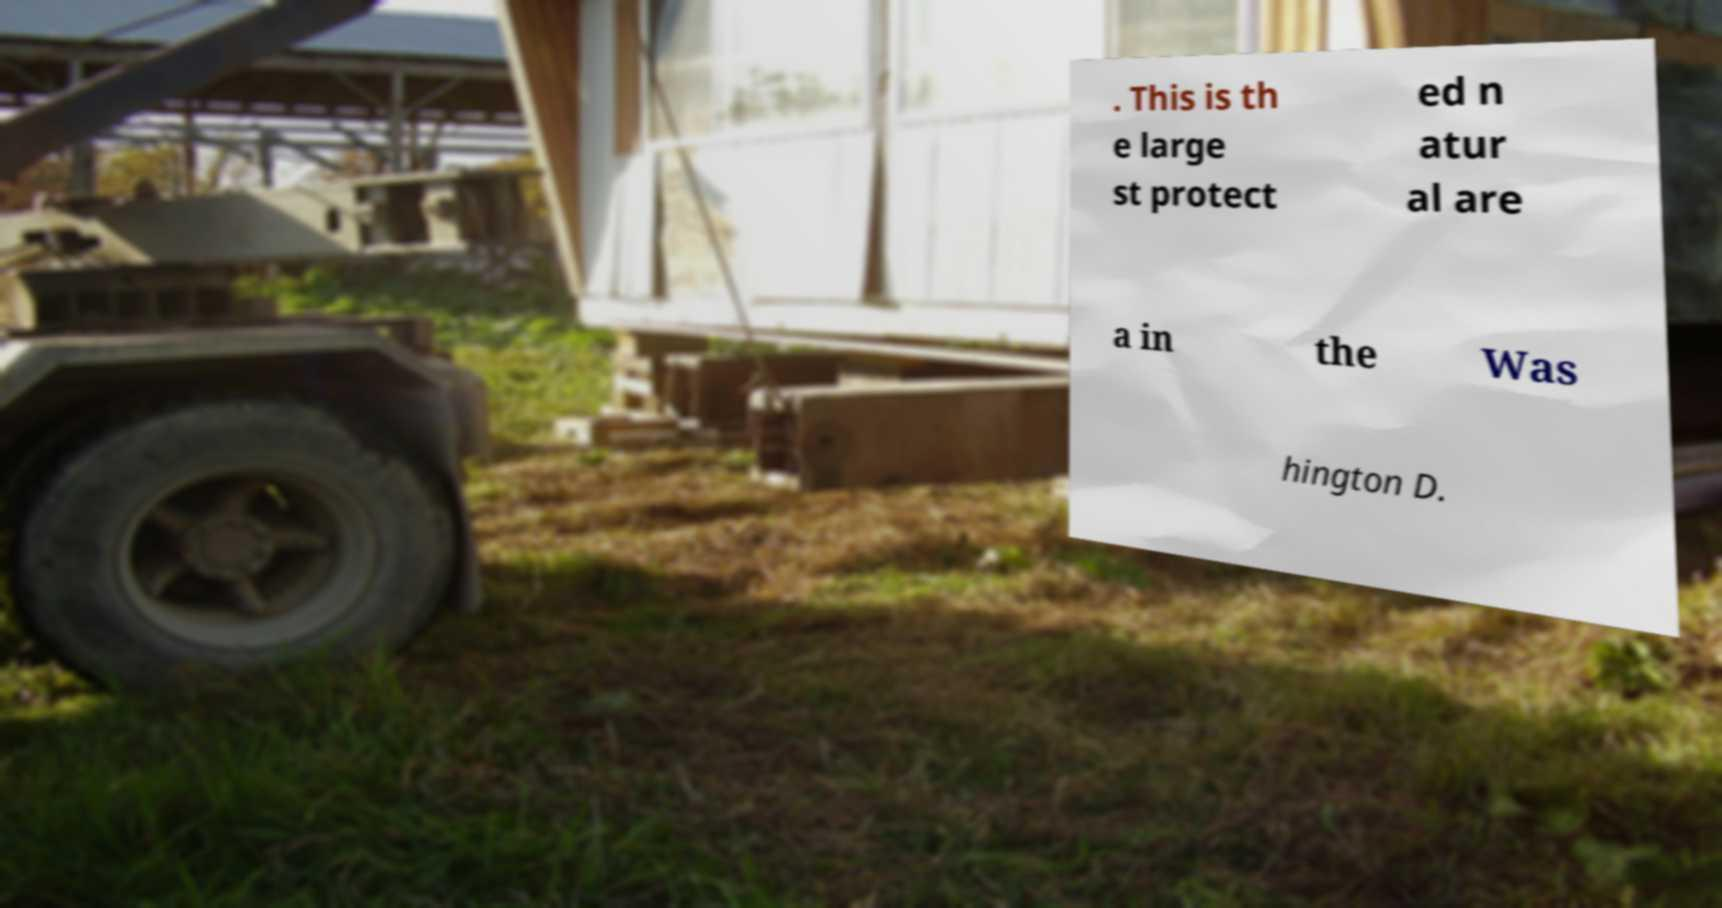What messages or text are displayed in this image? I need them in a readable, typed format. . This is th e large st protect ed n atur al are a in the Was hington D. 